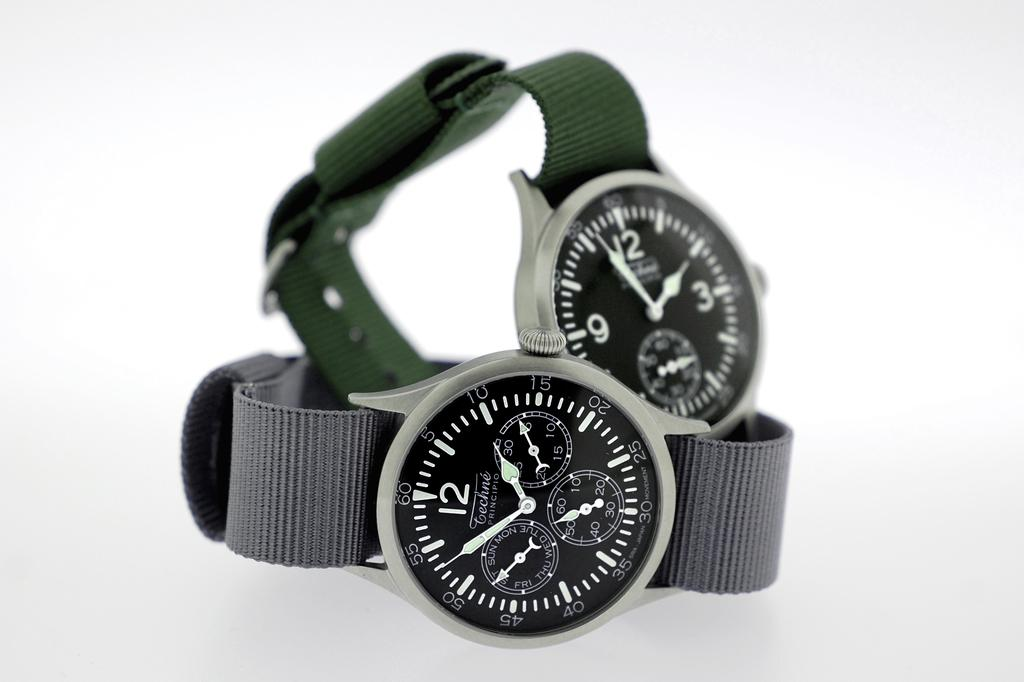<image>
Create a compact narrative representing the image presented. Two Techné Principio watches sit on top of each other in front of a white background. 